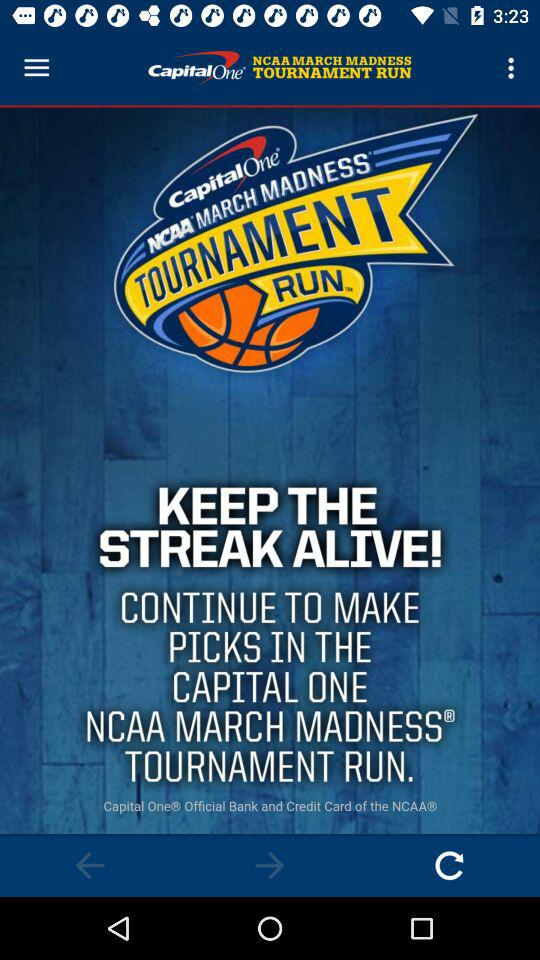Which team is ranked #1 in the tournament?
When the provided information is insufficient, respond with <no answer>. <no answer> 